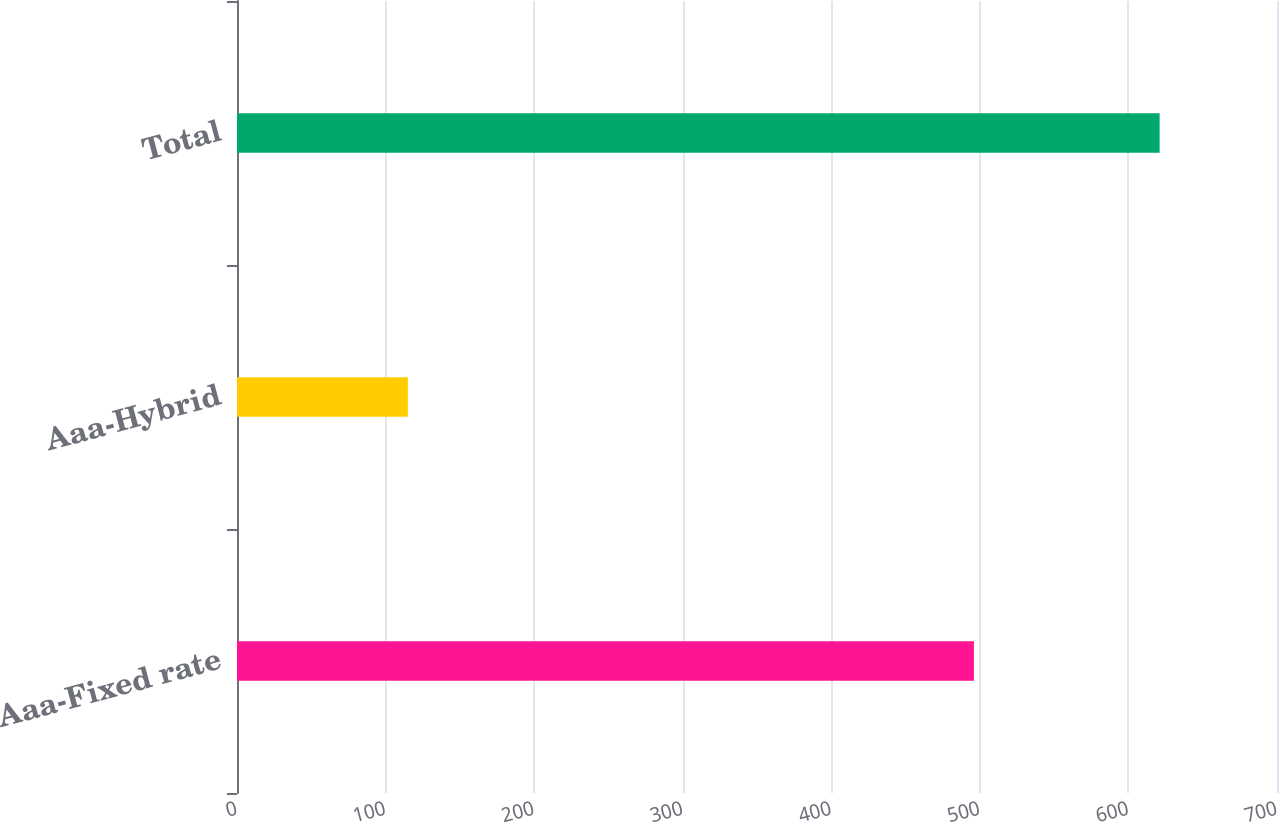<chart> <loc_0><loc_0><loc_500><loc_500><bar_chart><fcel>Aaa-Fixed rate<fcel>Aaa-Hybrid<fcel>Total<nl><fcel>496<fcel>115<fcel>621<nl></chart> 